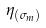<formula> <loc_0><loc_0><loc_500><loc_500>\eta _ { ( \sigma _ { m } ) }</formula> 